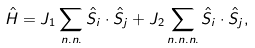<formula> <loc_0><loc_0><loc_500><loc_500>\hat { H } = J { _ { 1 } } \sum _ { n . n . } \hat { S } _ { i } \cdot \hat { S } _ { j } + J { _ { 2 } } \sum _ { n . n . n . } \hat { S } _ { i } \cdot \hat { S } _ { j } ,</formula> 